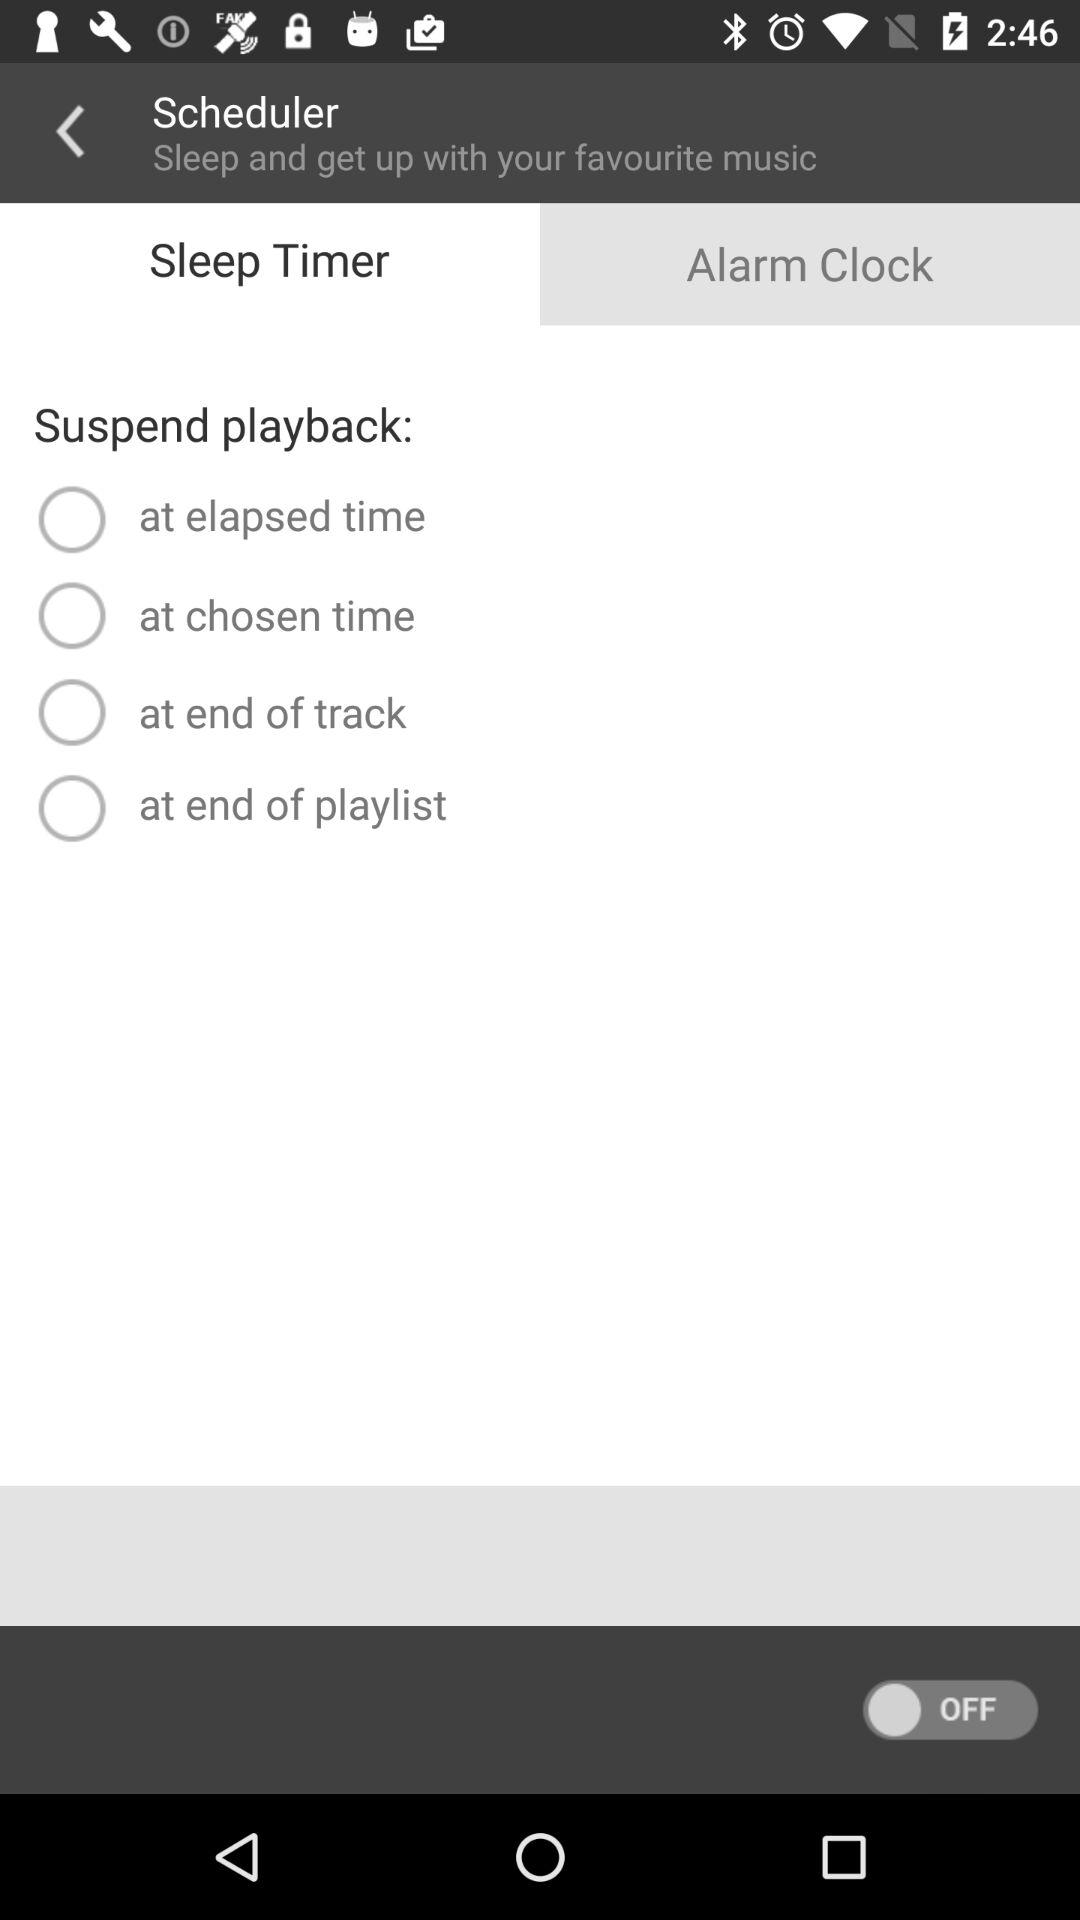What are the given options for the "Suspend playback"? The options are "at elapsed time", "at chosen time", "at end of track" and "at end of playlist". 